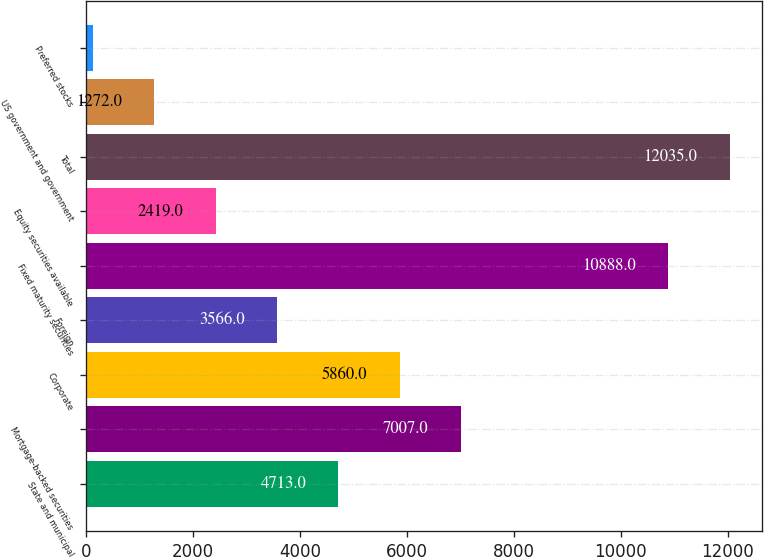Convert chart to OTSL. <chart><loc_0><loc_0><loc_500><loc_500><bar_chart><fcel>State and municipal<fcel>Mortgage-backed securities<fcel>Corporate<fcel>Foreign<fcel>Fixed maturity securities<fcel>Equity securities available<fcel>Total<fcel>US government and government<fcel>Preferred stocks<nl><fcel>4713<fcel>7007<fcel>5860<fcel>3566<fcel>10888<fcel>2419<fcel>12035<fcel>1272<fcel>125<nl></chart> 